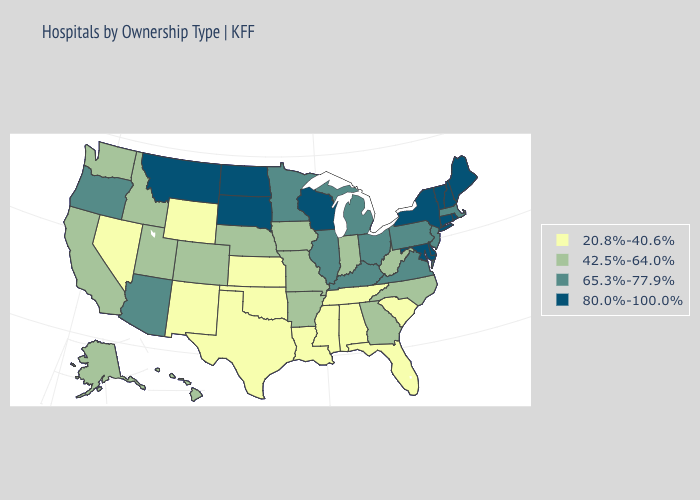Among the states that border Utah , does New Mexico have the lowest value?
Write a very short answer. Yes. Does the first symbol in the legend represent the smallest category?
Write a very short answer. Yes. Does Iowa have a higher value than Oklahoma?
Be succinct. Yes. Does New Hampshire have the highest value in the Northeast?
Be succinct. Yes. Which states have the highest value in the USA?
Quick response, please. Connecticut, Delaware, Maine, Maryland, Montana, New Hampshire, New York, North Dakota, Rhode Island, South Dakota, Vermont, Wisconsin. What is the value of Illinois?
Give a very brief answer. 65.3%-77.9%. Name the states that have a value in the range 20.8%-40.6%?
Keep it brief. Alabama, Florida, Kansas, Louisiana, Mississippi, Nevada, New Mexico, Oklahoma, South Carolina, Tennessee, Texas, Wyoming. What is the value of North Carolina?
Short answer required. 42.5%-64.0%. What is the highest value in the West ?
Short answer required. 80.0%-100.0%. Does Nebraska have a higher value than Oklahoma?
Concise answer only. Yes. What is the highest value in states that border Idaho?
Answer briefly. 80.0%-100.0%. Does Oregon have a lower value than Wisconsin?
Answer briefly. Yes. What is the highest value in the USA?
Give a very brief answer. 80.0%-100.0%. What is the value of Nebraska?
Write a very short answer. 42.5%-64.0%. Is the legend a continuous bar?
Write a very short answer. No. 